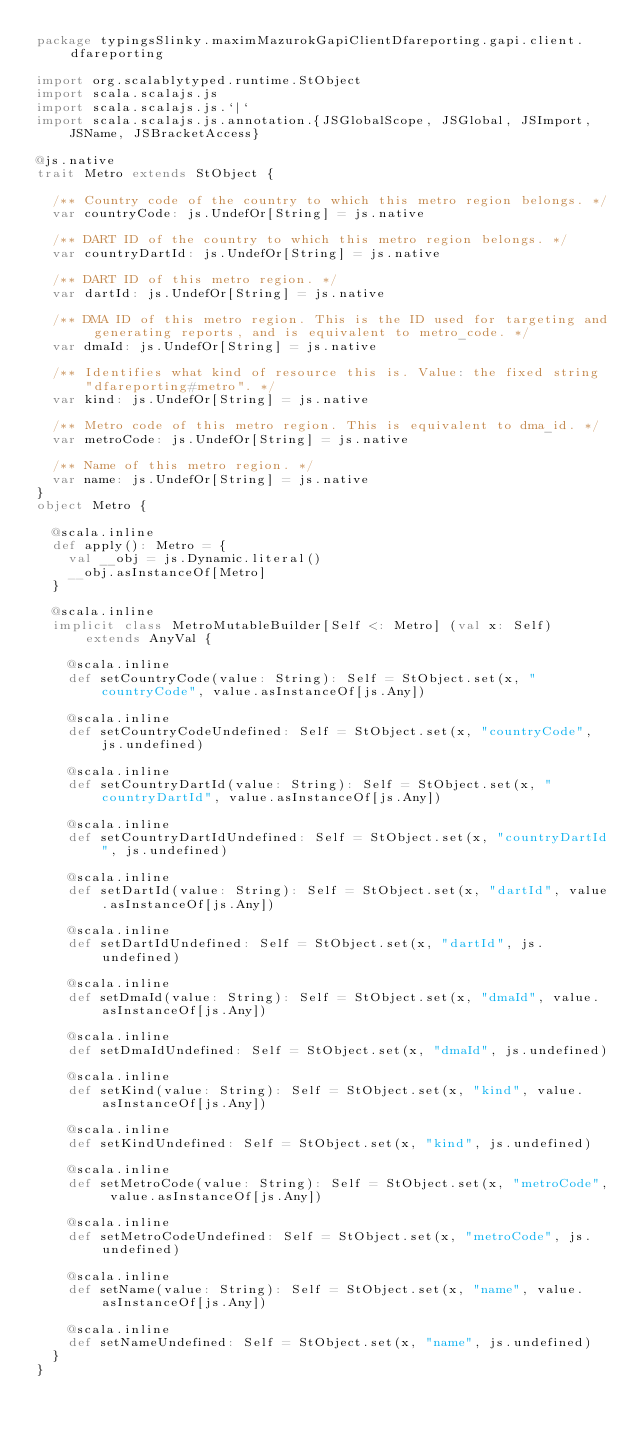<code> <loc_0><loc_0><loc_500><loc_500><_Scala_>package typingsSlinky.maximMazurokGapiClientDfareporting.gapi.client.dfareporting

import org.scalablytyped.runtime.StObject
import scala.scalajs.js
import scala.scalajs.js.`|`
import scala.scalajs.js.annotation.{JSGlobalScope, JSGlobal, JSImport, JSName, JSBracketAccess}

@js.native
trait Metro extends StObject {
  
  /** Country code of the country to which this metro region belongs. */
  var countryCode: js.UndefOr[String] = js.native
  
  /** DART ID of the country to which this metro region belongs. */
  var countryDartId: js.UndefOr[String] = js.native
  
  /** DART ID of this metro region. */
  var dartId: js.UndefOr[String] = js.native
  
  /** DMA ID of this metro region. This is the ID used for targeting and generating reports, and is equivalent to metro_code. */
  var dmaId: js.UndefOr[String] = js.native
  
  /** Identifies what kind of resource this is. Value: the fixed string "dfareporting#metro". */
  var kind: js.UndefOr[String] = js.native
  
  /** Metro code of this metro region. This is equivalent to dma_id. */
  var metroCode: js.UndefOr[String] = js.native
  
  /** Name of this metro region. */
  var name: js.UndefOr[String] = js.native
}
object Metro {
  
  @scala.inline
  def apply(): Metro = {
    val __obj = js.Dynamic.literal()
    __obj.asInstanceOf[Metro]
  }
  
  @scala.inline
  implicit class MetroMutableBuilder[Self <: Metro] (val x: Self) extends AnyVal {
    
    @scala.inline
    def setCountryCode(value: String): Self = StObject.set(x, "countryCode", value.asInstanceOf[js.Any])
    
    @scala.inline
    def setCountryCodeUndefined: Self = StObject.set(x, "countryCode", js.undefined)
    
    @scala.inline
    def setCountryDartId(value: String): Self = StObject.set(x, "countryDartId", value.asInstanceOf[js.Any])
    
    @scala.inline
    def setCountryDartIdUndefined: Self = StObject.set(x, "countryDartId", js.undefined)
    
    @scala.inline
    def setDartId(value: String): Self = StObject.set(x, "dartId", value.asInstanceOf[js.Any])
    
    @scala.inline
    def setDartIdUndefined: Self = StObject.set(x, "dartId", js.undefined)
    
    @scala.inline
    def setDmaId(value: String): Self = StObject.set(x, "dmaId", value.asInstanceOf[js.Any])
    
    @scala.inline
    def setDmaIdUndefined: Self = StObject.set(x, "dmaId", js.undefined)
    
    @scala.inline
    def setKind(value: String): Self = StObject.set(x, "kind", value.asInstanceOf[js.Any])
    
    @scala.inline
    def setKindUndefined: Self = StObject.set(x, "kind", js.undefined)
    
    @scala.inline
    def setMetroCode(value: String): Self = StObject.set(x, "metroCode", value.asInstanceOf[js.Any])
    
    @scala.inline
    def setMetroCodeUndefined: Self = StObject.set(x, "metroCode", js.undefined)
    
    @scala.inline
    def setName(value: String): Self = StObject.set(x, "name", value.asInstanceOf[js.Any])
    
    @scala.inline
    def setNameUndefined: Self = StObject.set(x, "name", js.undefined)
  }
}
</code> 